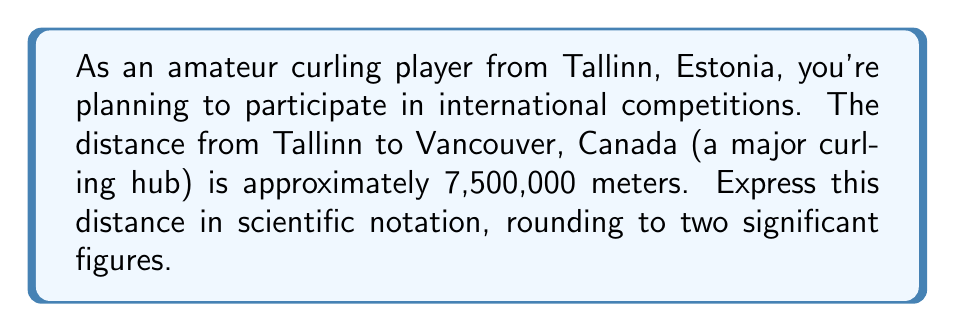Provide a solution to this math problem. To express the distance in scientific notation with two significant figures, we follow these steps:

1. Identify the significant figures:
   7,500,000 meters has two significant figures (7.5)

2. Move the decimal point to get a number between 1 and 10:
   $7.5 \times 10^6$ meters

3. The number is already in scientific notation form:
   $a \times 10^n$, where $1 \leq a < 10$ and $n$ is an integer

4. Check if rounding is needed:
   In this case, 7.5 is already rounded to two significant figures, so no further rounding is necessary.

Therefore, the distance from Tallinn to Vancouver expressed in scientific notation with two significant figures is $7.5 \times 10^6$ meters.
Answer: $7.5 \times 10^6$ meters 